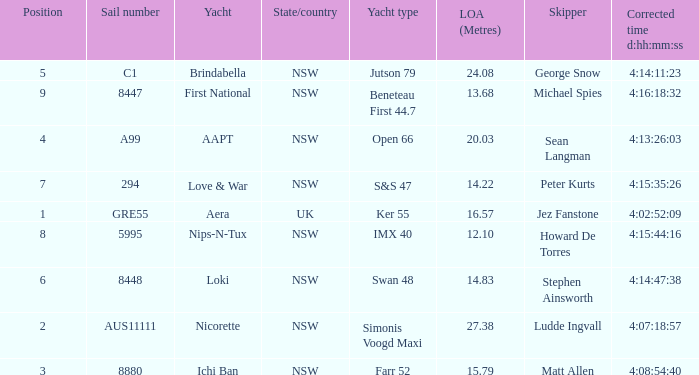What is the ranking for NSW open 66 racing boat.  4.0. 